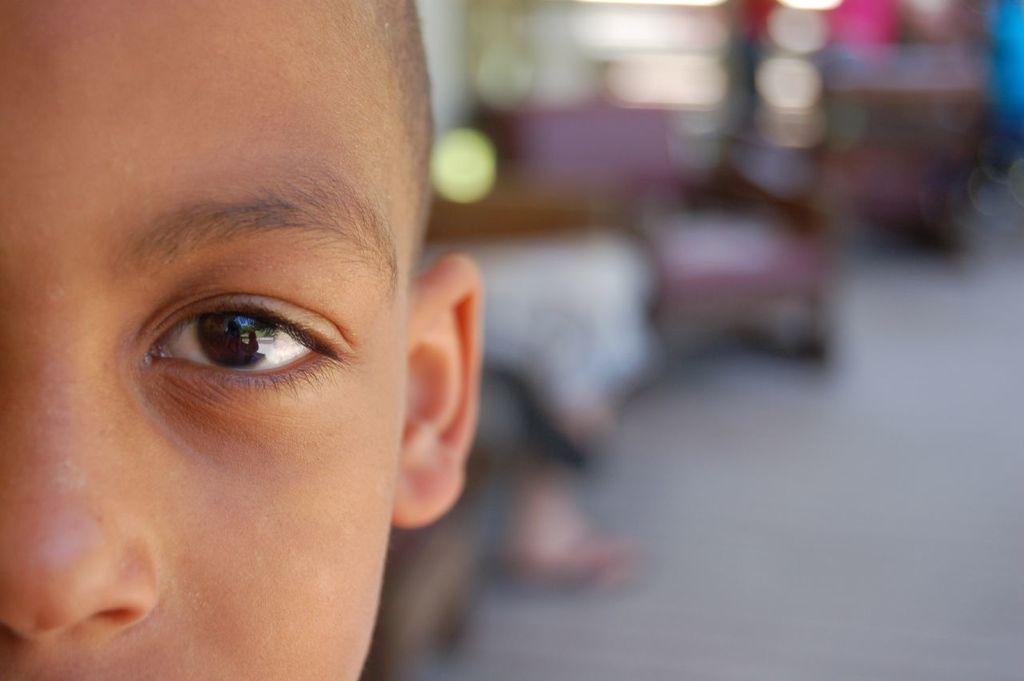Could you give a brief overview of what you see in this image? In this image we can see the face of a kid, and the background is blurred, 